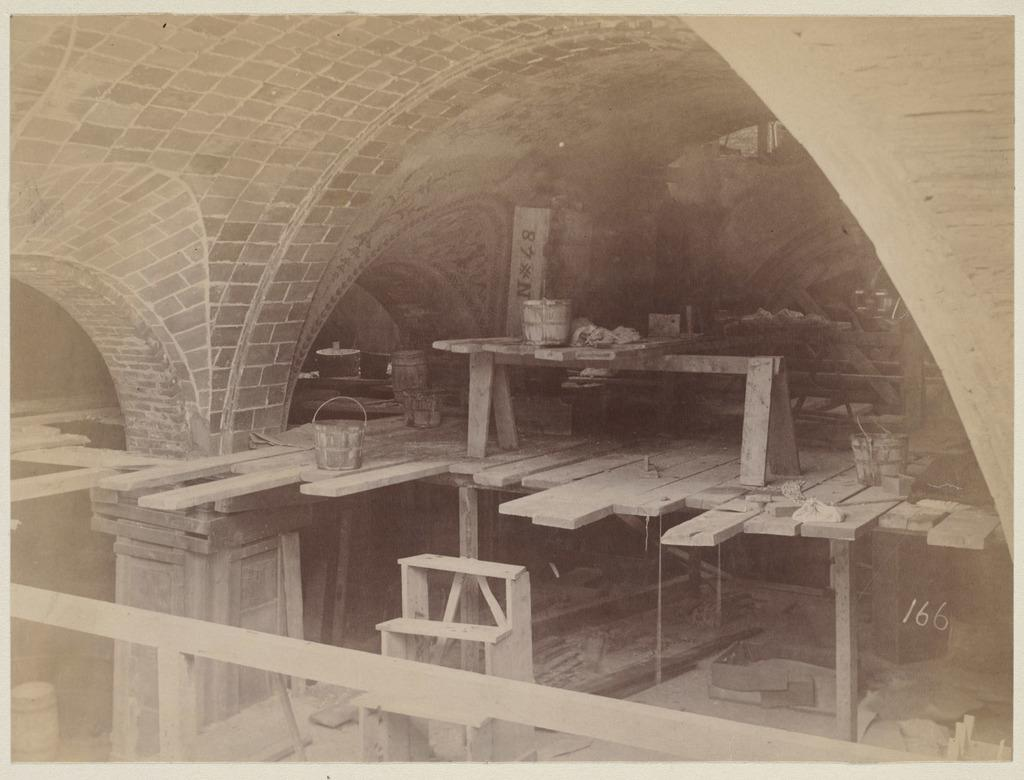What type of building is visible in the image? There is a stone constructed building in the image. What object can be seen near the building? There is a bucket in the image. What material is used for the sheets in the image? There are wooden sheets in the image. What surface is present in the image? There is a floor in the image. Is there any numerical information in the image? Yes, there is a number in the image. What type of feather can be seen floating in the image? There is no feather present in the image. Can you describe the sense of smell in the image? The sense of smell cannot be determined from the image, as it is a visual medium. 